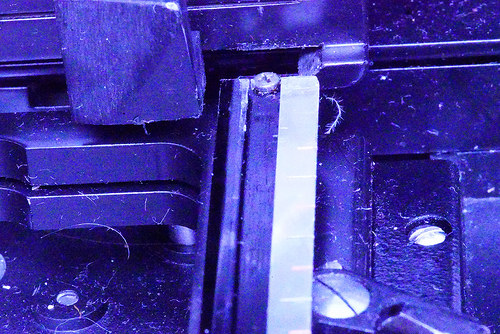<image>
Can you confirm if the screw is next to the grove? No. The screw is not positioned next to the grove. They are located in different areas of the scene. 